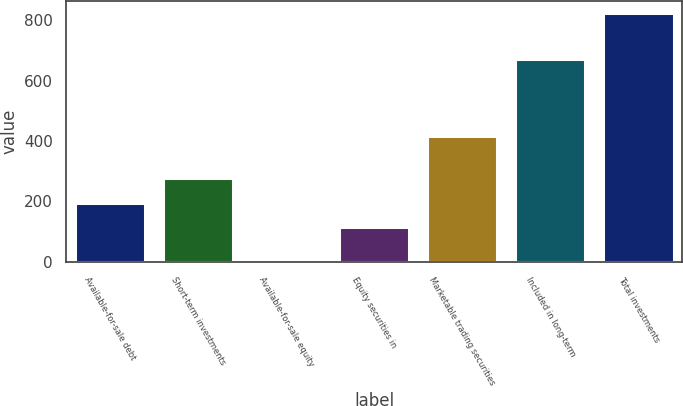<chart> <loc_0><loc_0><loc_500><loc_500><bar_chart><fcel>Available-for-sale debt<fcel>Short-term investments<fcel>Available-for-sale equity<fcel>Equity securities in<fcel>Marketable trading securities<fcel>Included in long-term<fcel>Total investments<nl><fcel>196.4<fcel>277.8<fcel>9<fcel>115<fcel>418<fcel>671<fcel>823<nl></chart> 